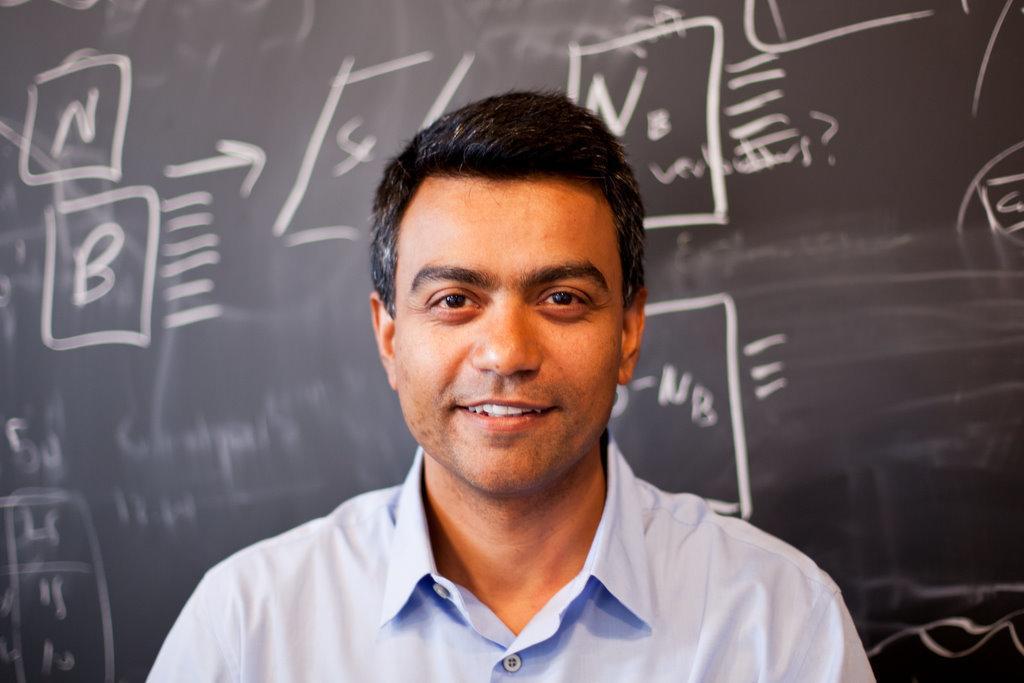Could you give a brief overview of what you see in this image? Here in this picture we can see a person in a white colored shirt present over there, smiling and behind him we can see a black board with something written on it over there. 